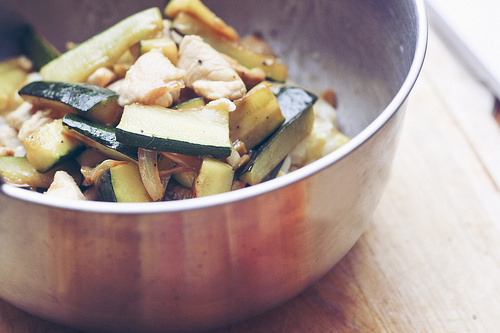<image>
Is there a bowl under the zucchini slice? Yes. The bowl is positioned underneath the zucchini slice, with the zucchini slice above it in the vertical space. 